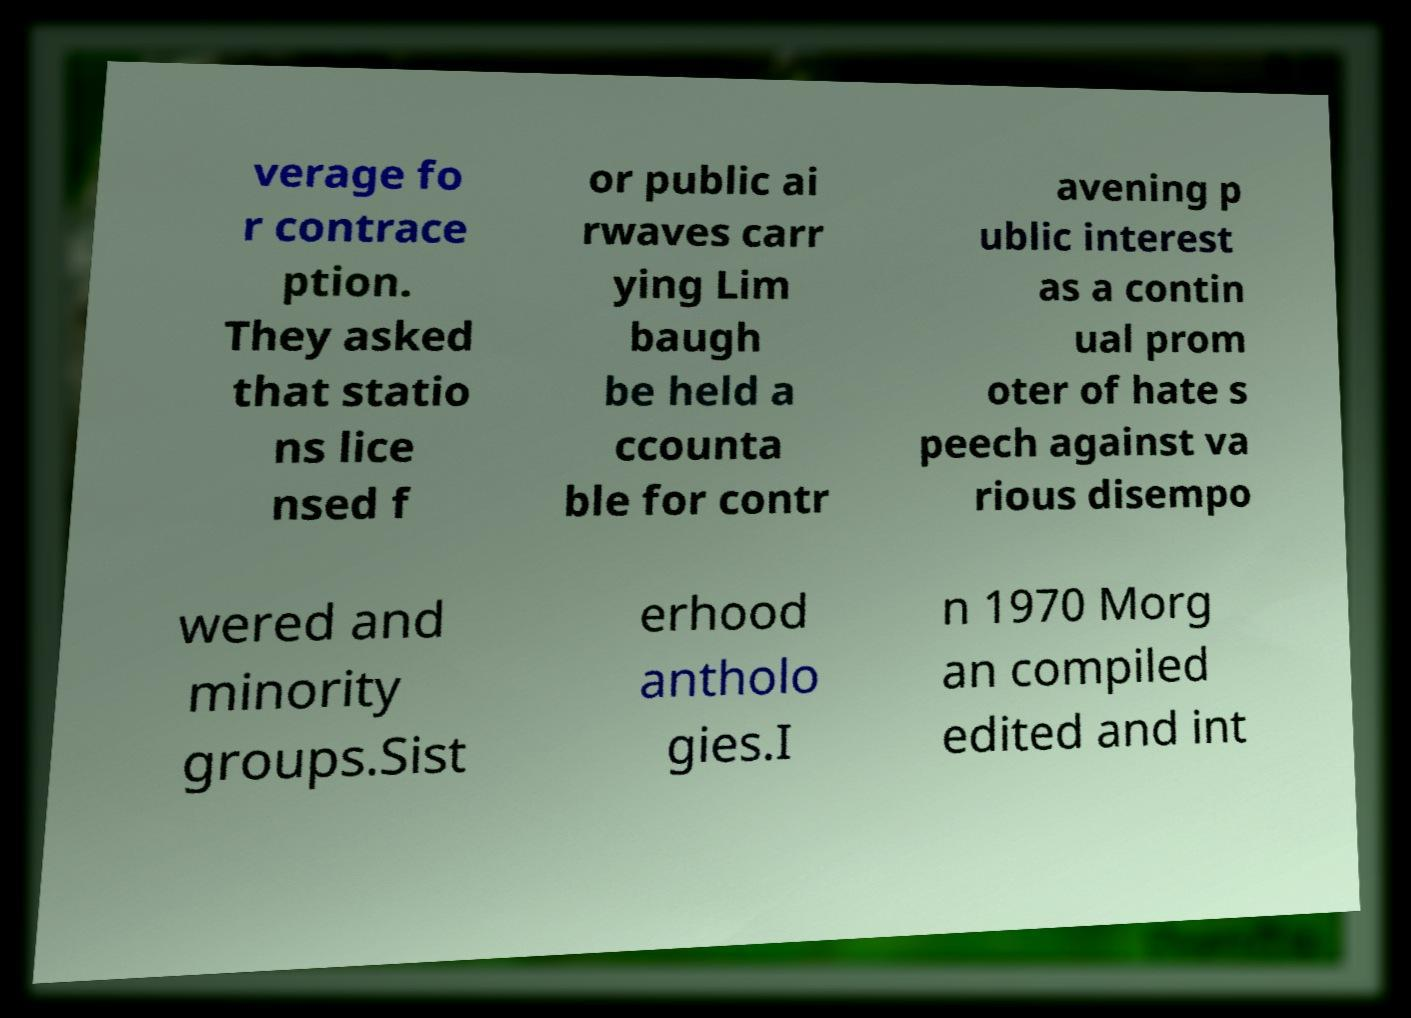There's text embedded in this image that I need extracted. Can you transcribe it verbatim? verage fo r contrace ption. They asked that statio ns lice nsed f or public ai rwaves carr ying Lim baugh be held a ccounta ble for contr avening p ublic interest as a contin ual prom oter of hate s peech against va rious disempo wered and minority groups.Sist erhood antholo gies.I n 1970 Morg an compiled edited and int 